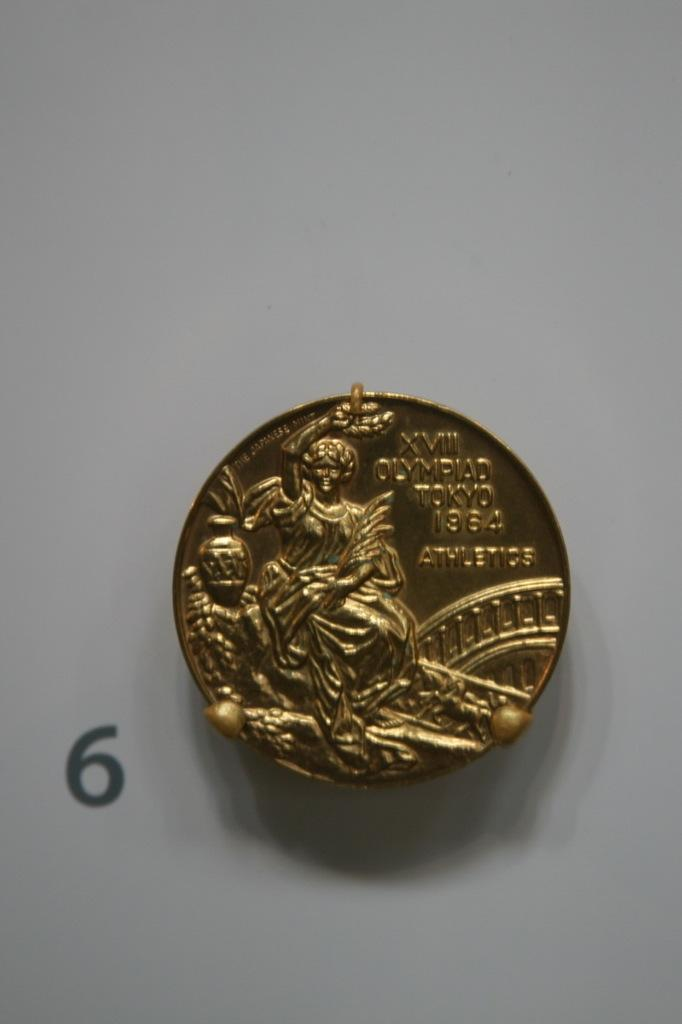<image>
Create a compact narrative representing the image presented. A gold piece with the engraving XVII OLYMPIAD TOKYO 1964 ATHLETICS 